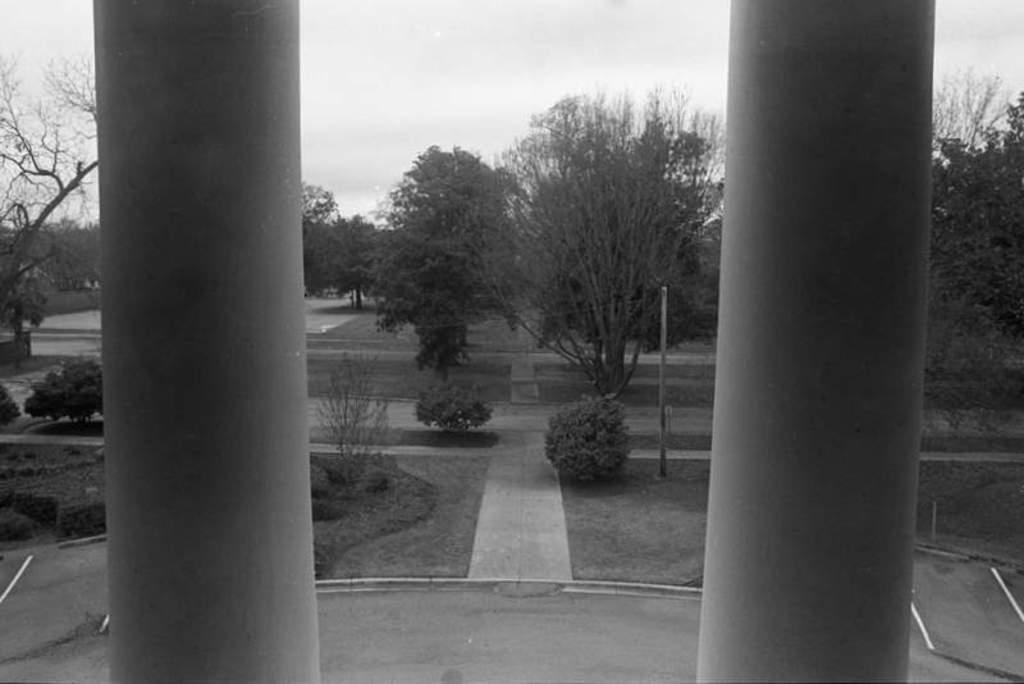What type of landscape is depicted in the image? There is a grassland in the image. Are there any other natural elements present in the image? Yes, there are trees in the image. Where are the grassland and trees located in the image? The grassland and trees are in the center of the image. What can be seen on the sides of the image? There are two pillars on both the right and left sides of the image. What type of wine is being served on the grassland in the image? There is no wine or any indication of a serving in the image; it features a grassland and trees. What type of dirt can be seen on the ground in the image? The image does not show any dirt on the ground; it features a grassland, which implies the presence of grass rather than dirt. 